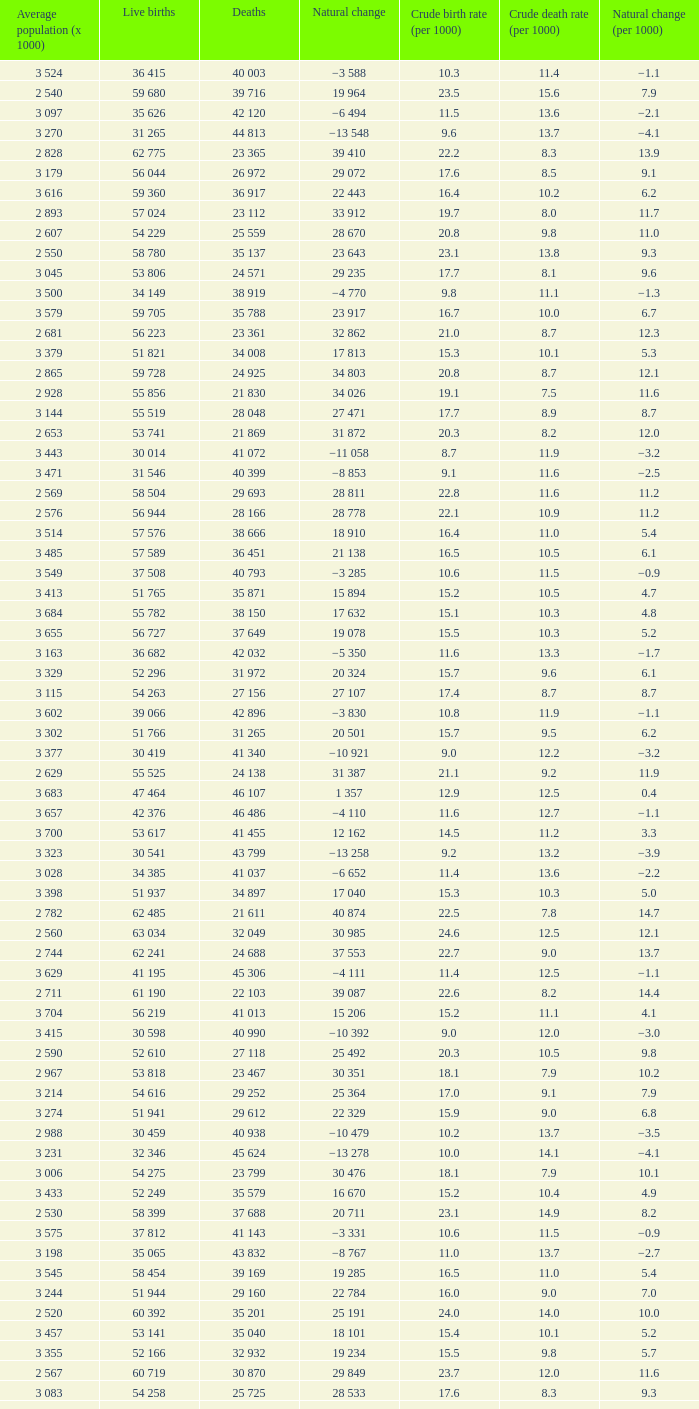Which Live births have a Natural change (per 1000) of 12.0? 53 741. 